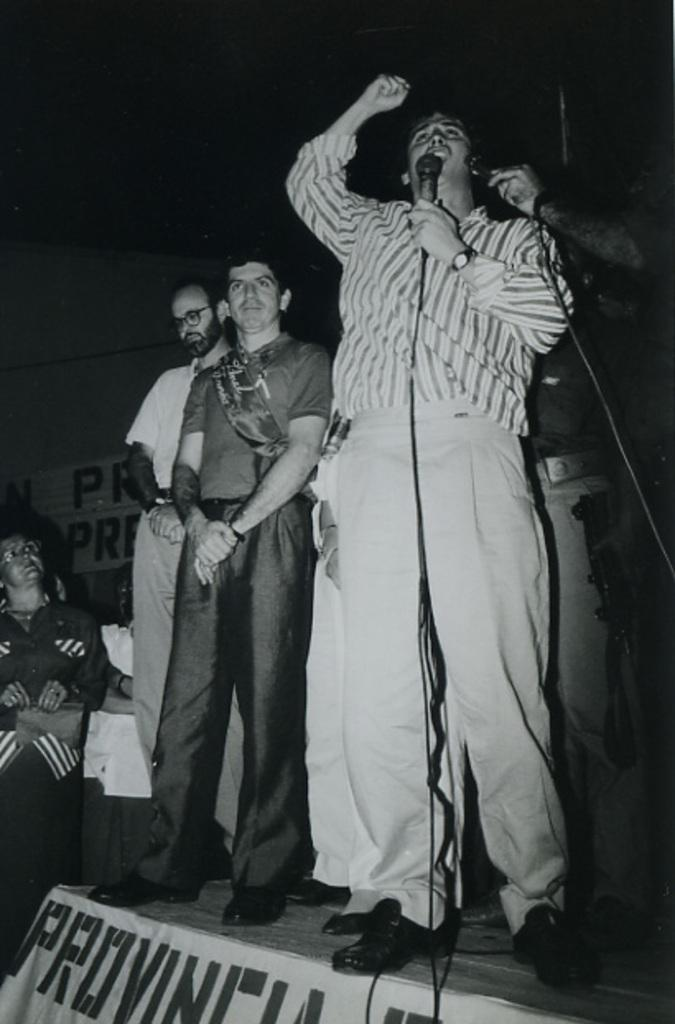How many people are in the image? There are people in the image, but the exact number is not specified. What is the person in front doing? The person in front is standing and holding a mic. What is the color scheme of the image? The image is in black and white. What type of grape is being used as an apparatus by the person in the image? There is no grape or apparatus present in the image; the person is holding a mic. 